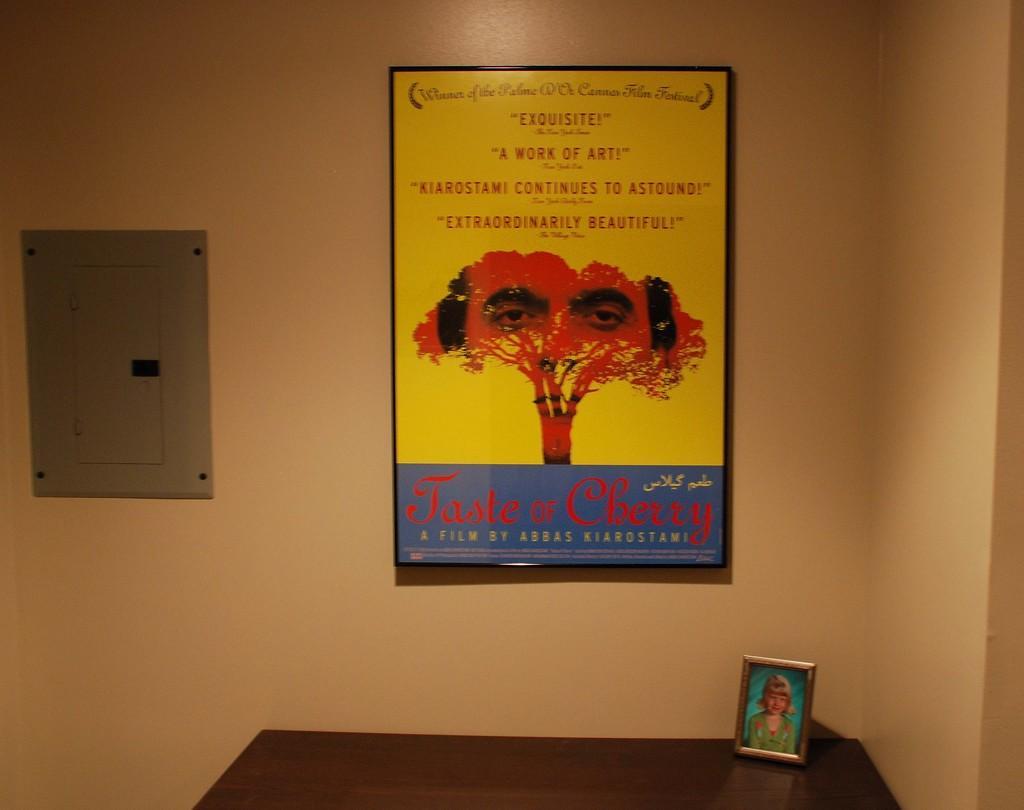In one or two sentences, can you explain what this image depicts? In this image we can see a frame to the wall, which is in yellow color on which we can see some text and an image of tree in which we can see a person's eyes, we can see a photo frame kept on the table. Here we can see the fuse box to the wall. 